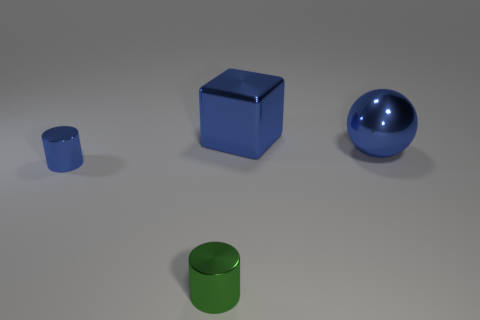Is the material of the tiny cylinder that is to the left of the green metal cylinder the same as the cube behind the tiny green thing?
Offer a terse response. Yes. What number of blue balls are the same size as the cube?
Ensure brevity in your answer.  1. What is the shape of the tiny shiny thing that is the same color as the big cube?
Make the answer very short. Cylinder. What is the material of the large blue object that is to the right of the metal block?
Your answer should be very brief. Metal. What number of other tiny shiny things have the same shape as the small green shiny object?
Provide a succinct answer. 1. There is another small thing that is the same material as the green thing; what shape is it?
Ensure brevity in your answer.  Cylinder. What shape is the metal thing that is on the left side of the small thing on the right side of the blue metallic cylinder to the left of the blue metal block?
Provide a short and direct response. Cylinder. Is the number of large metal things greater than the number of purple balls?
Your answer should be compact. Yes. There is another tiny object that is the same shape as the small blue thing; what is it made of?
Ensure brevity in your answer.  Metal. Does the big block have the same material as the green cylinder?
Give a very brief answer. Yes. 